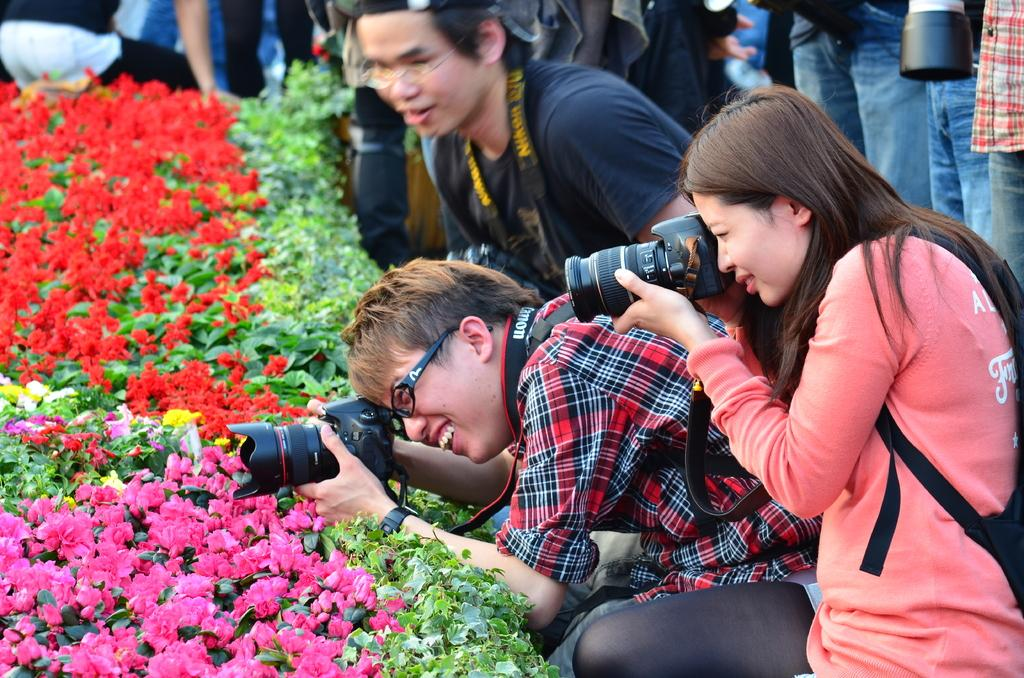How many people are in the image? There is a group of people in the image. What are two people in the group doing? Two people in the group are taking pictures with their cameras. What are the people taking pictures of? The people are taking pictures of flowers. Where are the flowers located in relation to the people taking pictures? The flowers are present in front of the people taking pictures. How many clocks can be seen in the image? There are no clocks visible in the image. Is there a fight happening between the people in the image? There is no indication of a fight in the image; the people are taking pictures of flowers. 